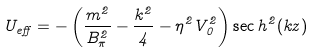Convert formula to latex. <formula><loc_0><loc_0><loc_500><loc_500>U _ { e f f } = - \left ( \frac { m ^ { 2 } } { B _ { \pi } ^ { 2 } } - \frac { k ^ { 2 } } { 4 } - \eta ^ { 2 } V _ { 0 } ^ { 2 } \right ) \sec h ^ { 2 } ( k z )</formula> 